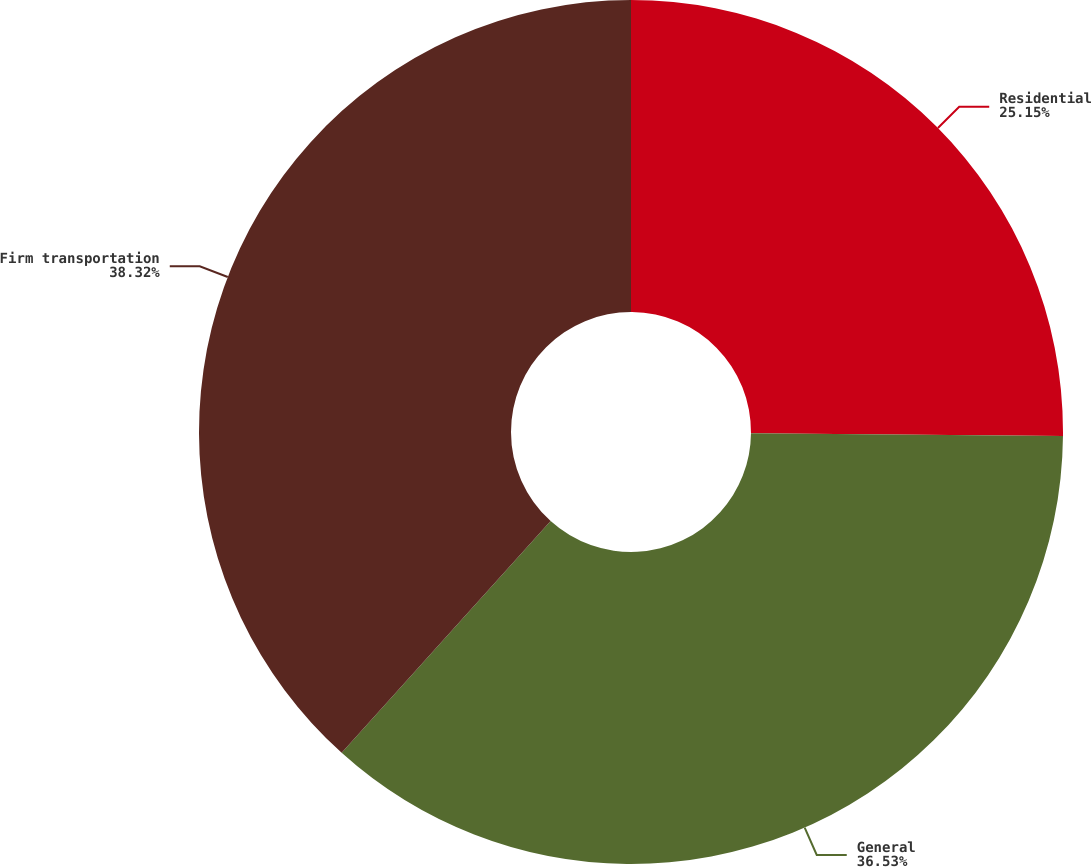Convert chart to OTSL. <chart><loc_0><loc_0><loc_500><loc_500><pie_chart><fcel>Residential<fcel>General<fcel>Firm transportation<nl><fcel>25.15%<fcel>36.53%<fcel>38.32%<nl></chart> 